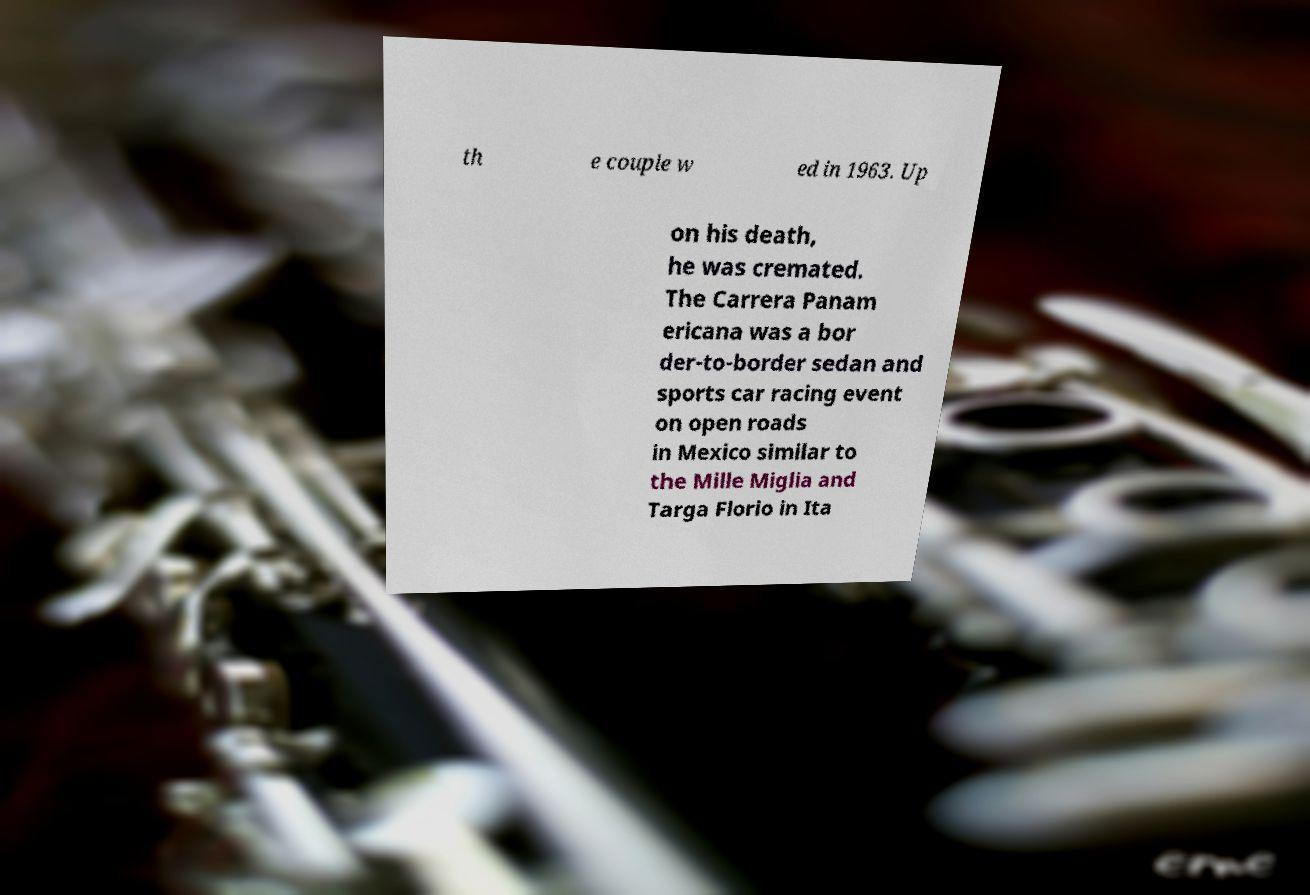Could you extract and type out the text from this image? th e couple w ed in 1963. Up on his death, he was cremated. The Carrera Panam ericana was a bor der-to-border sedan and sports car racing event on open roads in Mexico similar to the Mille Miglia and Targa Florio in Ita 